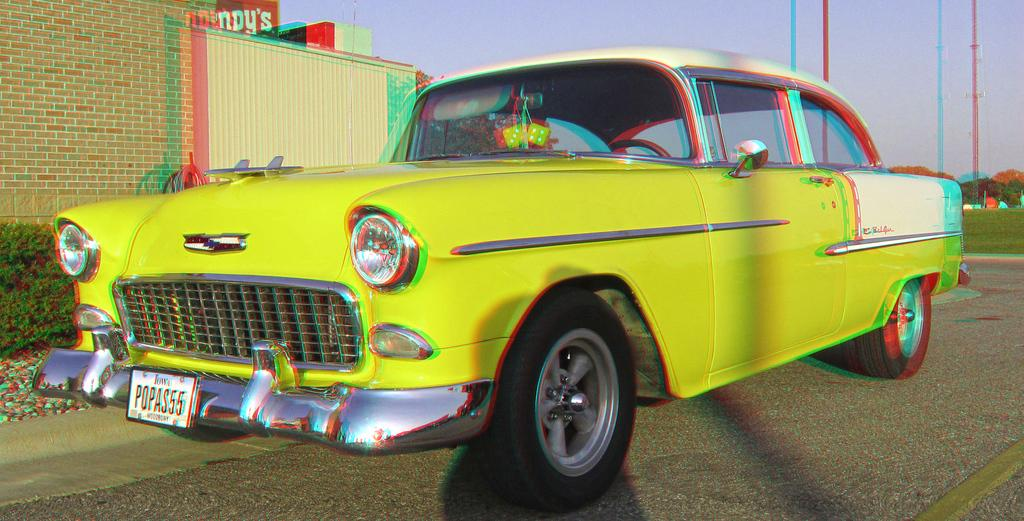<image>
Offer a succinct explanation of the picture presented. A yellow colored vintage automobile that is registered in Iowa. 